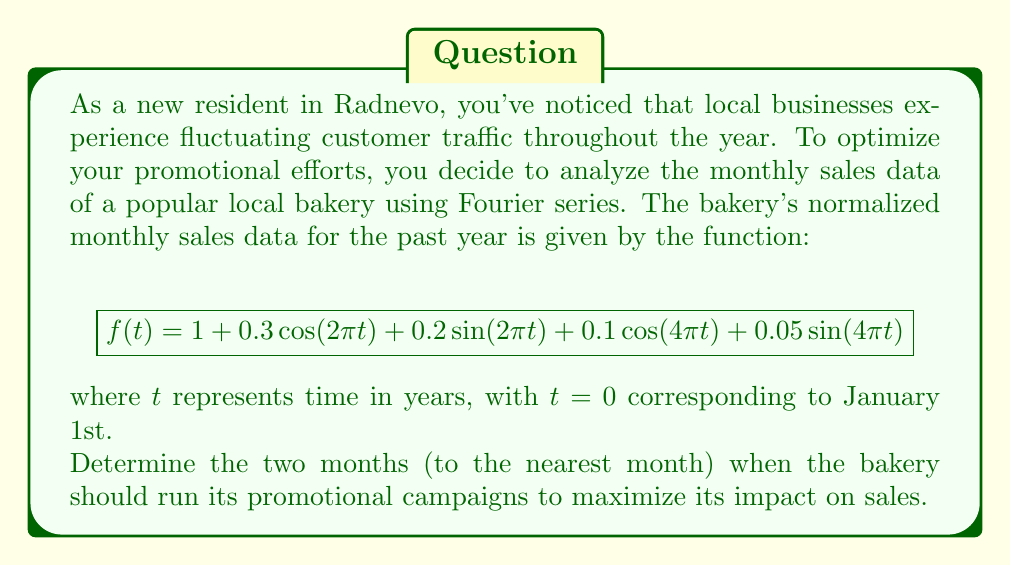Show me your answer to this math problem. To solve this problem, we need to analyze the given Fourier series and find its maximum values. The steps are as follows:

1) The function $f(t)$ represents the bakery's sales throughout the year. To find the optimal times for promotions, we need to locate the function's maxima.

2) The constant term 1 represents the average sales. The cosine and sine terms with $2\pi t$ represent yearly fluctuations, while those with $4\pi t$ represent semi-yearly fluctuations.

3) To find the maxima, we need to calculate the derivative $f'(t)$ and set it to zero:

   $$f'(t) = -0.3 \cdot 2\pi \sin(2\pi t) + 0.2 \cdot 2\pi \cos(2\pi t) - 0.1 \cdot 4\pi \sin(4\pi t) + 0.05 \cdot 4\pi \cos(4\pi t)$$

4) Setting $f'(t) = 0$ gives us a transcendental equation that's difficult to solve analytically. However, we can observe that the dominant terms are those with $2\pi t$, as they have larger coefficients.

5) Considering only the dominant terms, we can approximate the maxima by solving:

   $$-0.3 \sin(2\pi t) + 0.2 \cos(2\pi t) = 0$$

6) This simplifies to:

   $$\tan(2\pi t) = \frac{2}{3}$$

7) Solving this equation gives us:

   $$2\pi t = \arctan(\frac{2}{3}) + n\pi, \quad n = 0, 1$$

8) Converting to months (multiplying by 6/π), we get:

   $$t \approx 0.304 + 0.5n \quad \text{years}, \quad n = 0, 1$$

9) This corresponds to approximately 3.6 months and 9.6 months into the year.

Therefore, the optimal times for promotions are early April and early October.
Answer: The bakery should run its promotional campaigns in early April and early October (to the nearest month). 